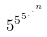<formula> <loc_0><loc_0><loc_500><loc_500>5 ^ { 5 ^ { 5 ^ { . ^ { . ^ { n } } } } }</formula> 